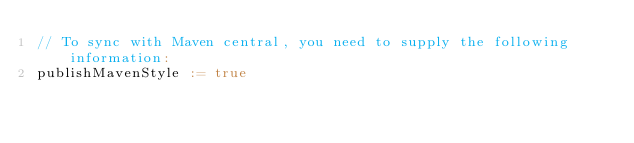Convert code to text. <code><loc_0><loc_0><loc_500><loc_500><_Scala_>// To sync with Maven central, you need to supply the following information:
publishMavenStyle := true
</code> 